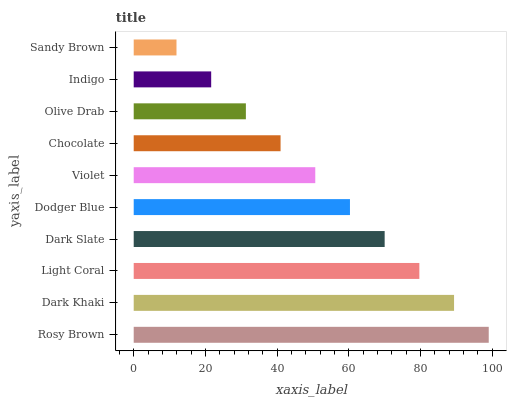Is Sandy Brown the minimum?
Answer yes or no. Yes. Is Rosy Brown the maximum?
Answer yes or no. Yes. Is Dark Khaki the minimum?
Answer yes or no. No. Is Dark Khaki the maximum?
Answer yes or no. No. Is Rosy Brown greater than Dark Khaki?
Answer yes or no. Yes. Is Dark Khaki less than Rosy Brown?
Answer yes or no. Yes. Is Dark Khaki greater than Rosy Brown?
Answer yes or no. No. Is Rosy Brown less than Dark Khaki?
Answer yes or no. No. Is Dodger Blue the high median?
Answer yes or no. Yes. Is Violet the low median?
Answer yes or no. Yes. Is Rosy Brown the high median?
Answer yes or no. No. Is Rosy Brown the low median?
Answer yes or no. No. 